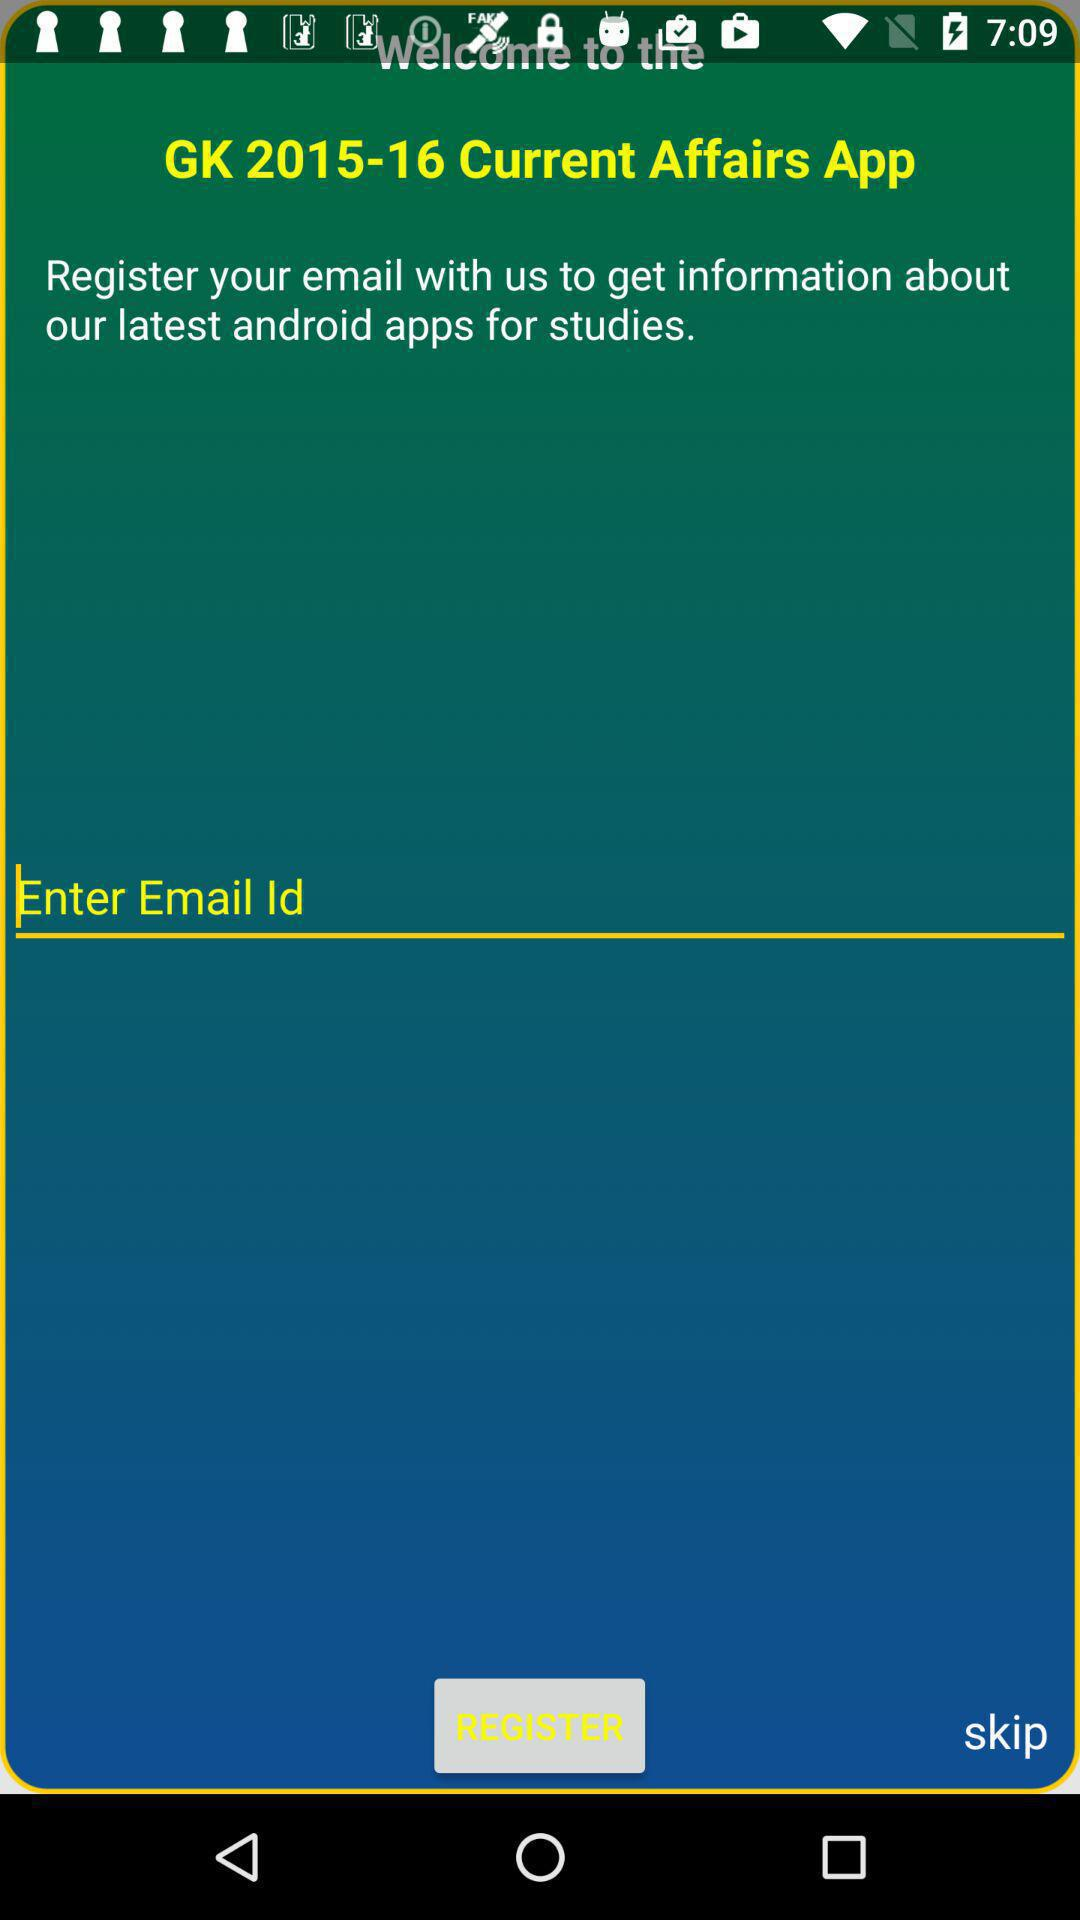What is the name of the application? The name of the application is "GK 2015-16 Current Affairs App". 